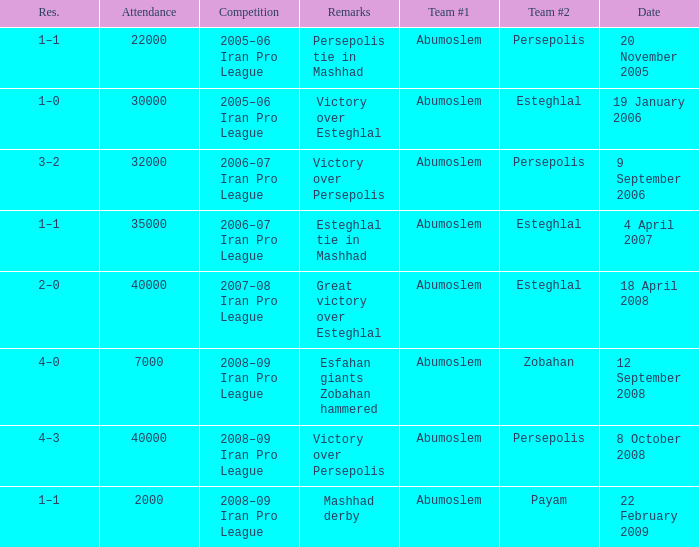What date was the attendance 22000? 20 November 2005. 